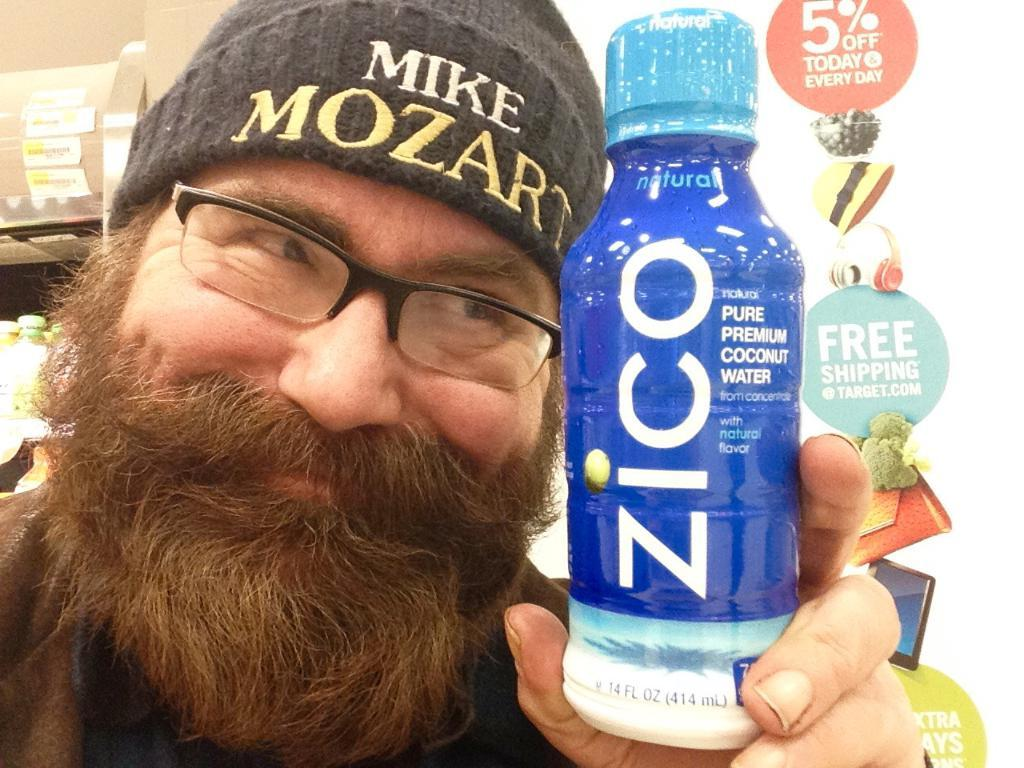What is the main subject of the image? There is a person in the image. What is the person doing in the image? The person is standing and holding a bottle. What is the person's facial expression in the image? The person is smiling. What can be seen in the background of the image? There is a wall in the background of the image. What is on the wall in the background? There is a banner on the wall. What type of ship can be seen in the image? There is no ship present in the image. How does the person twist the bottle in the image? The person is not twisting the bottle in the image; they are simply holding it. 